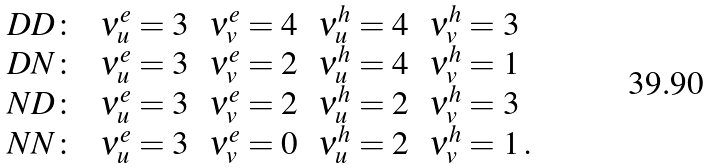<formula> <loc_0><loc_0><loc_500><loc_500>\begin{array} { l l l l l } D D \colon \, & \nu _ { u } ^ { e } = 3 \, & \nu _ { v } ^ { e } = 4 \, & \nu _ { u } ^ { h } = 4 \, & \nu _ { v } ^ { h } = 3 \\ D N \colon \, & \nu _ { u } ^ { e } = 3 \, & \nu _ { v } ^ { e } = 2 \, & \nu _ { u } ^ { h } = 4 \, & \nu _ { v } ^ { h } = 1 \\ N D \colon \, & \nu _ { u } ^ { e } = 3 \, & \nu _ { v } ^ { e } = 2 \, & \nu _ { u } ^ { h } = 2 \, & \nu _ { v } ^ { h } = 3 \\ N N \colon \, & \nu _ { u } ^ { e } = 3 \, & \nu _ { v } ^ { e } = 0 \, & \nu _ { u } ^ { h } = 2 \, & \nu _ { v } ^ { h } = 1 \, . \end{array}</formula> 